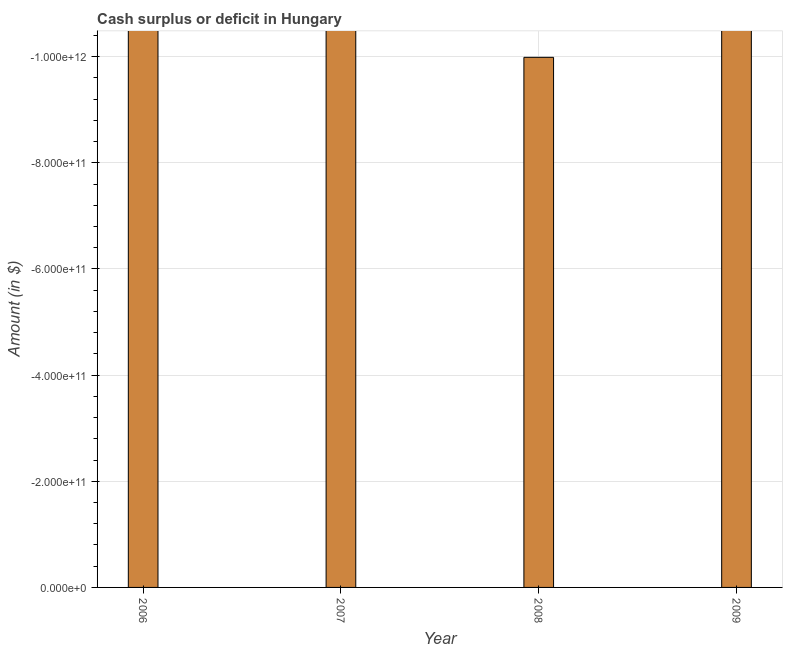What is the title of the graph?
Your answer should be very brief. Cash surplus or deficit in Hungary. What is the label or title of the Y-axis?
Your response must be concise. Amount (in $). What is the sum of the cash surplus or deficit?
Provide a short and direct response. 0. In how many years, is the cash surplus or deficit greater than the average cash surplus or deficit taken over all years?
Keep it short and to the point. 0. Are all the bars in the graph horizontal?
Your answer should be compact. No. What is the difference between two consecutive major ticks on the Y-axis?
Offer a very short reply. 2.00e+11. What is the Amount (in $) of 2006?
Your answer should be compact. 0. What is the Amount (in $) in 2007?
Ensure brevity in your answer.  0. What is the Amount (in $) in 2008?
Ensure brevity in your answer.  0. 